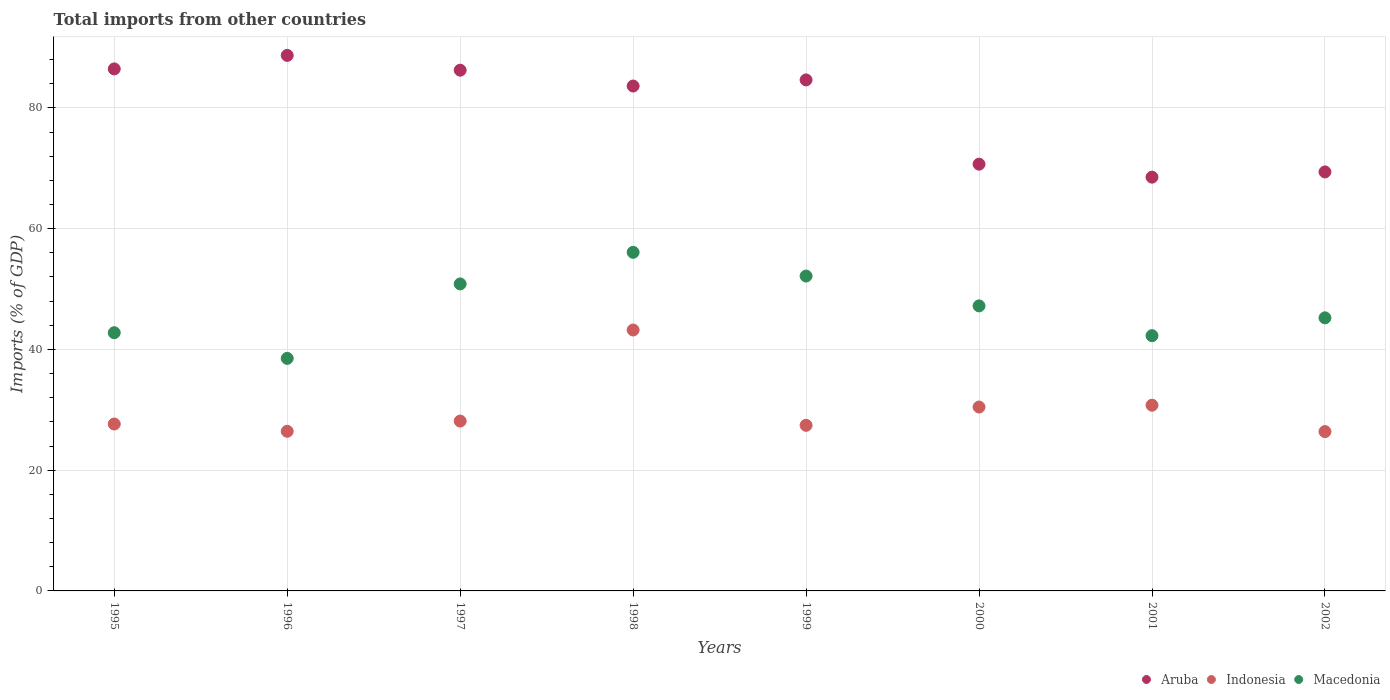How many different coloured dotlines are there?
Provide a succinct answer. 3. What is the total imports in Indonesia in 2000?
Offer a terse response. 30.46. Across all years, what is the maximum total imports in Aruba?
Provide a short and direct response. 88.7. Across all years, what is the minimum total imports in Indonesia?
Keep it short and to the point. 26.39. In which year was the total imports in Macedonia minimum?
Ensure brevity in your answer.  1996. What is the total total imports in Macedonia in the graph?
Ensure brevity in your answer.  375.1. What is the difference between the total imports in Aruba in 2001 and that in 2002?
Ensure brevity in your answer.  -0.87. What is the difference between the total imports in Macedonia in 1999 and the total imports in Aruba in 2001?
Keep it short and to the point. -16.38. What is the average total imports in Aruba per year?
Offer a very short reply. 79.79. In the year 1999, what is the difference between the total imports in Aruba and total imports in Macedonia?
Provide a short and direct response. 32.49. What is the ratio of the total imports in Aruba in 1995 to that in 1996?
Make the answer very short. 0.97. Is the total imports in Indonesia in 1998 less than that in 2002?
Make the answer very short. No. What is the difference between the highest and the second highest total imports in Aruba?
Your response must be concise. 2.24. What is the difference between the highest and the lowest total imports in Aruba?
Provide a short and direct response. 20.17. In how many years, is the total imports in Indonesia greater than the average total imports in Indonesia taken over all years?
Keep it short and to the point. 3. Does the total imports in Aruba monotonically increase over the years?
Give a very brief answer. No. Is the total imports in Indonesia strictly greater than the total imports in Macedonia over the years?
Offer a very short reply. No. Is the total imports in Indonesia strictly less than the total imports in Aruba over the years?
Keep it short and to the point. Yes. How many dotlines are there?
Give a very brief answer. 3. Does the graph contain any zero values?
Keep it short and to the point. No. Where does the legend appear in the graph?
Make the answer very short. Bottom right. How many legend labels are there?
Keep it short and to the point. 3. How are the legend labels stacked?
Your response must be concise. Horizontal. What is the title of the graph?
Keep it short and to the point. Total imports from other countries. Does "Latvia" appear as one of the legend labels in the graph?
Your answer should be very brief. No. What is the label or title of the Y-axis?
Offer a terse response. Imports (% of GDP). What is the Imports (% of GDP) of Aruba in 1995?
Provide a succinct answer. 86.46. What is the Imports (% of GDP) of Indonesia in 1995?
Your answer should be very brief. 27.65. What is the Imports (% of GDP) of Macedonia in 1995?
Provide a succinct answer. 42.77. What is the Imports (% of GDP) of Aruba in 1996?
Keep it short and to the point. 88.7. What is the Imports (% of GDP) of Indonesia in 1996?
Provide a succinct answer. 26.44. What is the Imports (% of GDP) of Macedonia in 1996?
Keep it short and to the point. 38.52. What is the Imports (% of GDP) of Aruba in 1997?
Provide a short and direct response. 86.25. What is the Imports (% of GDP) of Indonesia in 1997?
Make the answer very short. 28.13. What is the Imports (% of GDP) in Macedonia in 1997?
Offer a very short reply. 50.85. What is the Imports (% of GDP) in Aruba in 1998?
Ensure brevity in your answer.  83.63. What is the Imports (% of GDP) in Indonesia in 1998?
Your response must be concise. 43.22. What is the Imports (% of GDP) of Macedonia in 1998?
Provide a succinct answer. 56.09. What is the Imports (% of GDP) of Aruba in 1999?
Offer a terse response. 84.64. What is the Imports (% of GDP) in Indonesia in 1999?
Give a very brief answer. 27.43. What is the Imports (% of GDP) of Macedonia in 1999?
Offer a very short reply. 52.15. What is the Imports (% of GDP) of Aruba in 2000?
Provide a succinct answer. 70.69. What is the Imports (% of GDP) of Indonesia in 2000?
Your answer should be compact. 30.46. What is the Imports (% of GDP) of Macedonia in 2000?
Ensure brevity in your answer.  47.21. What is the Imports (% of GDP) of Aruba in 2001?
Your response must be concise. 68.53. What is the Imports (% of GDP) in Indonesia in 2001?
Offer a very short reply. 30.76. What is the Imports (% of GDP) of Macedonia in 2001?
Your answer should be very brief. 42.28. What is the Imports (% of GDP) of Aruba in 2002?
Provide a succinct answer. 69.4. What is the Imports (% of GDP) of Indonesia in 2002?
Offer a terse response. 26.39. What is the Imports (% of GDP) of Macedonia in 2002?
Your response must be concise. 45.23. Across all years, what is the maximum Imports (% of GDP) of Aruba?
Offer a terse response. 88.7. Across all years, what is the maximum Imports (% of GDP) in Indonesia?
Provide a short and direct response. 43.22. Across all years, what is the maximum Imports (% of GDP) in Macedonia?
Your response must be concise. 56.09. Across all years, what is the minimum Imports (% of GDP) of Aruba?
Your answer should be compact. 68.53. Across all years, what is the minimum Imports (% of GDP) in Indonesia?
Offer a very short reply. 26.39. Across all years, what is the minimum Imports (% of GDP) in Macedonia?
Your response must be concise. 38.52. What is the total Imports (% of GDP) in Aruba in the graph?
Offer a terse response. 638.31. What is the total Imports (% of GDP) in Indonesia in the graph?
Give a very brief answer. 240.48. What is the total Imports (% of GDP) in Macedonia in the graph?
Offer a terse response. 375.1. What is the difference between the Imports (% of GDP) in Aruba in 1995 and that in 1996?
Offer a terse response. -2.24. What is the difference between the Imports (% of GDP) of Indonesia in 1995 and that in 1996?
Give a very brief answer. 1.21. What is the difference between the Imports (% of GDP) of Macedonia in 1995 and that in 1996?
Provide a short and direct response. 4.25. What is the difference between the Imports (% of GDP) in Aruba in 1995 and that in 1997?
Give a very brief answer. 0.21. What is the difference between the Imports (% of GDP) in Indonesia in 1995 and that in 1997?
Your response must be concise. -0.49. What is the difference between the Imports (% of GDP) in Macedonia in 1995 and that in 1997?
Offer a very short reply. -8.08. What is the difference between the Imports (% of GDP) of Aruba in 1995 and that in 1998?
Offer a terse response. 2.83. What is the difference between the Imports (% of GDP) of Indonesia in 1995 and that in 1998?
Make the answer very short. -15.57. What is the difference between the Imports (% of GDP) of Macedonia in 1995 and that in 1998?
Make the answer very short. -13.32. What is the difference between the Imports (% of GDP) of Aruba in 1995 and that in 1999?
Keep it short and to the point. 1.82. What is the difference between the Imports (% of GDP) of Indonesia in 1995 and that in 1999?
Ensure brevity in your answer.  0.22. What is the difference between the Imports (% of GDP) in Macedonia in 1995 and that in 1999?
Keep it short and to the point. -9.39. What is the difference between the Imports (% of GDP) of Aruba in 1995 and that in 2000?
Ensure brevity in your answer.  15.78. What is the difference between the Imports (% of GDP) in Indonesia in 1995 and that in 2000?
Your answer should be compact. -2.81. What is the difference between the Imports (% of GDP) in Macedonia in 1995 and that in 2000?
Make the answer very short. -4.45. What is the difference between the Imports (% of GDP) in Aruba in 1995 and that in 2001?
Provide a short and direct response. 17.93. What is the difference between the Imports (% of GDP) of Indonesia in 1995 and that in 2001?
Give a very brief answer. -3.11. What is the difference between the Imports (% of GDP) in Macedonia in 1995 and that in 2001?
Give a very brief answer. 0.49. What is the difference between the Imports (% of GDP) of Aruba in 1995 and that in 2002?
Give a very brief answer. 17.06. What is the difference between the Imports (% of GDP) of Indonesia in 1995 and that in 2002?
Give a very brief answer. 1.25. What is the difference between the Imports (% of GDP) in Macedonia in 1995 and that in 2002?
Give a very brief answer. -2.46. What is the difference between the Imports (% of GDP) in Aruba in 1996 and that in 1997?
Make the answer very short. 2.45. What is the difference between the Imports (% of GDP) in Indonesia in 1996 and that in 1997?
Offer a very short reply. -1.69. What is the difference between the Imports (% of GDP) in Macedonia in 1996 and that in 1997?
Provide a short and direct response. -12.33. What is the difference between the Imports (% of GDP) in Aruba in 1996 and that in 1998?
Offer a very short reply. 5.07. What is the difference between the Imports (% of GDP) of Indonesia in 1996 and that in 1998?
Your answer should be very brief. -16.78. What is the difference between the Imports (% of GDP) of Macedonia in 1996 and that in 1998?
Offer a very short reply. -17.57. What is the difference between the Imports (% of GDP) in Aruba in 1996 and that in 1999?
Provide a short and direct response. 4.06. What is the difference between the Imports (% of GDP) of Indonesia in 1996 and that in 1999?
Your response must be concise. -0.99. What is the difference between the Imports (% of GDP) in Macedonia in 1996 and that in 1999?
Make the answer very short. -13.64. What is the difference between the Imports (% of GDP) of Aruba in 1996 and that in 2000?
Make the answer very short. 18.02. What is the difference between the Imports (% of GDP) in Indonesia in 1996 and that in 2000?
Provide a succinct answer. -4.02. What is the difference between the Imports (% of GDP) in Macedonia in 1996 and that in 2000?
Your answer should be compact. -8.7. What is the difference between the Imports (% of GDP) of Aruba in 1996 and that in 2001?
Your answer should be compact. 20.17. What is the difference between the Imports (% of GDP) in Indonesia in 1996 and that in 2001?
Offer a very short reply. -4.32. What is the difference between the Imports (% of GDP) of Macedonia in 1996 and that in 2001?
Your response must be concise. -3.76. What is the difference between the Imports (% of GDP) of Aruba in 1996 and that in 2002?
Provide a succinct answer. 19.3. What is the difference between the Imports (% of GDP) of Indonesia in 1996 and that in 2002?
Provide a short and direct response. 0.05. What is the difference between the Imports (% of GDP) in Macedonia in 1996 and that in 2002?
Your answer should be very brief. -6.72. What is the difference between the Imports (% of GDP) of Aruba in 1997 and that in 1998?
Offer a very short reply. 2.62. What is the difference between the Imports (% of GDP) in Indonesia in 1997 and that in 1998?
Provide a short and direct response. -15.08. What is the difference between the Imports (% of GDP) in Macedonia in 1997 and that in 1998?
Provide a succinct answer. -5.24. What is the difference between the Imports (% of GDP) of Aruba in 1997 and that in 1999?
Your response must be concise. 1.61. What is the difference between the Imports (% of GDP) in Indonesia in 1997 and that in 1999?
Provide a succinct answer. 0.7. What is the difference between the Imports (% of GDP) of Macedonia in 1997 and that in 1999?
Make the answer very short. -1.3. What is the difference between the Imports (% of GDP) in Aruba in 1997 and that in 2000?
Give a very brief answer. 15.56. What is the difference between the Imports (% of GDP) in Indonesia in 1997 and that in 2000?
Provide a short and direct response. -2.32. What is the difference between the Imports (% of GDP) of Macedonia in 1997 and that in 2000?
Your response must be concise. 3.64. What is the difference between the Imports (% of GDP) in Aruba in 1997 and that in 2001?
Offer a very short reply. 17.72. What is the difference between the Imports (% of GDP) of Indonesia in 1997 and that in 2001?
Your answer should be very brief. -2.63. What is the difference between the Imports (% of GDP) in Macedonia in 1997 and that in 2001?
Make the answer very short. 8.57. What is the difference between the Imports (% of GDP) of Aruba in 1997 and that in 2002?
Your answer should be compact. 16.85. What is the difference between the Imports (% of GDP) in Indonesia in 1997 and that in 2002?
Your response must be concise. 1.74. What is the difference between the Imports (% of GDP) of Macedonia in 1997 and that in 2002?
Ensure brevity in your answer.  5.62. What is the difference between the Imports (% of GDP) of Aruba in 1998 and that in 1999?
Make the answer very short. -1.01. What is the difference between the Imports (% of GDP) of Indonesia in 1998 and that in 1999?
Ensure brevity in your answer.  15.79. What is the difference between the Imports (% of GDP) of Macedonia in 1998 and that in 1999?
Offer a terse response. 3.93. What is the difference between the Imports (% of GDP) in Aruba in 1998 and that in 2000?
Your response must be concise. 12.94. What is the difference between the Imports (% of GDP) in Indonesia in 1998 and that in 2000?
Ensure brevity in your answer.  12.76. What is the difference between the Imports (% of GDP) of Macedonia in 1998 and that in 2000?
Ensure brevity in your answer.  8.87. What is the difference between the Imports (% of GDP) in Aruba in 1998 and that in 2001?
Provide a short and direct response. 15.1. What is the difference between the Imports (% of GDP) of Indonesia in 1998 and that in 2001?
Ensure brevity in your answer.  12.46. What is the difference between the Imports (% of GDP) in Macedonia in 1998 and that in 2001?
Provide a succinct answer. 13.81. What is the difference between the Imports (% of GDP) of Aruba in 1998 and that in 2002?
Provide a succinct answer. 14.23. What is the difference between the Imports (% of GDP) in Indonesia in 1998 and that in 2002?
Your answer should be very brief. 16.83. What is the difference between the Imports (% of GDP) in Macedonia in 1998 and that in 2002?
Give a very brief answer. 10.85. What is the difference between the Imports (% of GDP) of Aruba in 1999 and that in 2000?
Your answer should be very brief. 13.96. What is the difference between the Imports (% of GDP) in Indonesia in 1999 and that in 2000?
Your answer should be very brief. -3.03. What is the difference between the Imports (% of GDP) of Macedonia in 1999 and that in 2000?
Keep it short and to the point. 4.94. What is the difference between the Imports (% of GDP) of Aruba in 1999 and that in 2001?
Ensure brevity in your answer.  16.11. What is the difference between the Imports (% of GDP) in Indonesia in 1999 and that in 2001?
Provide a short and direct response. -3.33. What is the difference between the Imports (% of GDP) of Macedonia in 1999 and that in 2001?
Make the answer very short. 9.87. What is the difference between the Imports (% of GDP) in Aruba in 1999 and that in 2002?
Make the answer very short. 15.24. What is the difference between the Imports (% of GDP) in Indonesia in 1999 and that in 2002?
Give a very brief answer. 1.04. What is the difference between the Imports (% of GDP) of Macedonia in 1999 and that in 2002?
Provide a succinct answer. 6.92. What is the difference between the Imports (% of GDP) of Aruba in 2000 and that in 2001?
Offer a terse response. 2.15. What is the difference between the Imports (% of GDP) in Indonesia in 2000 and that in 2001?
Provide a short and direct response. -0.3. What is the difference between the Imports (% of GDP) of Macedonia in 2000 and that in 2001?
Your answer should be very brief. 4.93. What is the difference between the Imports (% of GDP) of Aruba in 2000 and that in 2002?
Ensure brevity in your answer.  1.29. What is the difference between the Imports (% of GDP) of Indonesia in 2000 and that in 2002?
Offer a very short reply. 4.07. What is the difference between the Imports (% of GDP) of Macedonia in 2000 and that in 2002?
Your answer should be compact. 1.98. What is the difference between the Imports (% of GDP) of Aruba in 2001 and that in 2002?
Your answer should be compact. -0.87. What is the difference between the Imports (% of GDP) in Indonesia in 2001 and that in 2002?
Your answer should be compact. 4.37. What is the difference between the Imports (% of GDP) in Macedonia in 2001 and that in 2002?
Ensure brevity in your answer.  -2.95. What is the difference between the Imports (% of GDP) of Aruba in 1995 and the Imports (% of GDP) of Indonesia in 1996?
Your response must be concise. 60.02. What is the difference between the Imports (% of GDP) of Aruba in 1995 and the Imports (% of GDP) of Macedonia in 1996?
Give a very brief answer. 47.95. What is the difference between the Imports (% of GDP) of Indonesia in 1995 and the Imports (% of GDP) of Macedonia in 1996?
Keep it short and to the point. -10.87. What is the difference between the Imports (% of GDP) in Aruba in 1995 and the Imports (% of GDP) in Indonesia in 1997?
Offer a very short reply. 58.33. What is the difference between the Imports (% of GDP) of Aruba in 1995 and the Imports (% of GDP) of Macedonia in 1997?
Provide a short and direct response. 35.61. What is the difference between the Imports (% of GDP) of Indonesia in 1995 and the Imports (% of GDP) of Macedonia in 1997?
Your response must be concise. -23.2. What is the difference between the Imports (% of GDP) in Aruba in 1995 and the Imports (% of GDP) in Indonesia in 1998?
Keep it short and to the point. 43.25. What is the difference between the Imports (% of GDP) in Aruba in 1995 and the Imports (% of GDP) in Macedonia in 1998?
Your response must be concise. 30.38. What is the difference between the Imports (% of GDP) in Indonesia in 1995 and the Imports (% of GDP) in Macedonia in 1998?
Offer a very short reply. -28.44. What is the difference between the Imports (% of GDP) of Aruba in 1995 and the Imports (% of GDP) of Indonesia in 1999?
Ensure brevity in your answer.  59.03. What is the difference between the Imports (% of GDP) of Aruba in 1995 and the Imports (% of GDP) of Macedonia in 1999?
Give a very brief answer. 34.31. What is the difference between the Imports (% of GDP) of Indonesia in 1995 and the Imports (% of GDP) of Macedonia in 1999?
Make the answer very short. -24.51. What is the difference between the Imports (% of GDP) in Aruba in 1995 and the Imports (% of GDP) in Indonesia in 2000?
Offer a terse response. 56. What is the difference between the Imports (% of GDP) of Aruba in 1995 and the Imports (% of GDP) of Macedonia in 2000?
Make the answer very short. 39.25. What is the difference between the Imports (% of GDP) in Indonesia in 1995 and the Imports (% of GDP) in Macedonia in 2000?
Your answer should be very brief. -19.57. What is the difference between the Imports (% of GDP) in Aruba in 1995 and the Imports (% of GDP) in Indonesia in 2001?
Offer a very short reply. 55.7. What is the difference between the Imports (% of GDP) in Aruba in 1995 and the Imports (% of GDP) in Macedonia in 2001?
Provide a succinct answer. 44.18. What is the difference between the Imports (% of GDP) of Indonesia in 1995 and the Imports (% of GDP) of Macedonia in 2001?
Your answer should be compact. -14.63. What is the difference between the Imports (% of GDP) in Aruba in 1995 and the Imports (% of GDP) in Indonesia in 2002?
Provide a succinct answer. 60.07. What is the difference between the Imports (% of GDP) of Aruba in 1995 and the Imports (% of GDP) of Macedonia in 2002?
Keep it short and to the point. 41.23. What is the difference between the Imports (% of GDP) of Indonesia in 1995 and the Imports (% of GDP) of Macedonia in 2002?
Provide a short and direct response. -17.59. What is the difference between the Imports (% of GDP) of Aruba in 1996 and the Imports (% of GDP) of Indonesia in 1997?
Provide a short and direct response. 60.57. What is the difference between the Imports (% of GDP) of Aruba in 1996 and the Imports (% of GDP) of Macedonia in 1997?
Provide a succinct answer. 37.85. What is the difference between the Imports (% of GDP) in Indonesia in 1996 and the Imports (% of GDP) in Macedonia in 1997?
Keep it short and to the point. -24.41. What is the difference between the Imports (% of GDP) of Aruba in 1996 and the Imports (% of GDP) of Indonesia in 1998?
Your response must be concise. 45.49. What is the difference between the Imports (% of GDP) of Aruba in 1996 and the Imports (% of GDP) of Macedonia in 1998?
Ensure brevity in your answer.  32.62. What is the difference between the Imports (% of GDP) in Indonesia in 1996 and the Imports (% of GDP) in Macedonia in 1998?
Provide a short and direct response. -29.65. What is the difference between the Imports (% of GDP) in Aruba in 1996 and the Imports (% of GDP) in Indonesia in 1999?
Offer a terse response. 61.27. What is the difference between the Imports (% of GDP) of Aruba in 1996 and the Imports (% of GDP) of Macedonia in 1999?
Your answer should be compact. 36.55. What is the difference between the Imports (% of GDP) of Indonesia in 1996 and the Imports (% of GDP) of Macedonia in 1999?
Offer a very short reply. -25.71. What is the difference between the Imports (% of GDP) in Aruba in 1996 and the Imports (% of GDP) in Indonesia in 2000?
Your answer should be very brief. 58.24. What is the difference between the Imports (% of GDP) of Aruba in 1996 and the Imports (% of GDP) of Macedonia in 2000?
Offer a terse response. 41.49. What is the difference between the Imports (% of GDP) of Indonesia in 1996 and the Imports (% of GDP) of Macedonia in 2000?
Provide a short and direct response. -20.77. What is the difference between the Imports (% of GDP) in Aruba in 1996 and the Imports (% of GDP) in Indonesia in 2001?
Your answer should be very brief. 57.94. What is the difference between the Imports (% of GDP) of Aruba in 1996 and the Imports (% of GDP) of Macedonia in 2001?
Give a very brief answer. 46.43. What is the difference between the Imports (% of GDP) in Indonesia in 1996 and the Imports (% of GDP) in Macedonia in 2001?
Offer a very short reply. -15.84. What is the difference between the Imports (% of GDP) of Aruba in 1996 and the Imports (% of GDP) of Indonesia in 2002?
Your answer should be compact. 62.31. What is the difference between the Imports (% of GDP) in Aruba in 1996 and the Imports (% of GDP) in Macedonia in 2002?
Your answer should be compact. 43.47. What is the difference between the Imports (% of GDP) of Indonesia in 1996 and the Imports (% of GDP) of Macedonia in 2002?
Your answer should be compact. -18.79. What is the difference between the Imports (% of GDP) of Aruba in 1997 and the Imports (% of GDP) of Indonesia in 1998?
Your answer should be compact. 43.03. What is the difference between the Imports (% of GDP) of Aruba in 1997 and the Imports (% of GDP) of Macedonia in 1998?
Keep it short and to the point. 30.17. What is the difference between the Imports (% of GDP) in Indonesia in 1997 and the Imports (% of GDP) in Macedonia in 1998?
Provide a succinct answer. -27.95. What is the difference between the Imports (% of GDP) in Aruba in 1997 and the Imports (% of GDP) in Indonesia in 1999?
Ensure brevity in your answer.  58.82. What is the difference between the Imports (% of GDP) of Aruba in 1997 and the Imports (% of GDP) of Macedonia in 1999?
Provide a short and direct response. 34.1. What is the difference between the Imports (% of GDP) of Indonesia in 1997 and the Imports (% of GDP) of Macedonia in 1999?
Your answer should be very brief. -24.02. What is the difference between the Imports (% of GDP) of Aruba in 1997 and the Imports (% of GDP) of Indonesia in 2000?
Ensure brevity in your answer.  55.79. What is the difference between the Imports (% of GDP) of Aruba in 1997 and the Imports (% of GDP) of Macedonia in 2000?
Give a very brief answer. 39.04. What is the difference between the Imports (% of GDP) of Indonesia in 1997 and the Imports (% of GDP) of Macedonia in 2000?
Offer a very short reply. -19.08. What is the difference between the Imports (% of GDP) in Aruba in 1997 and the Imports (% of GDP) in Indonesia in 2001?
Make the answer very short. 55.49. What is the difference between the Imports (% of GDP) of Aruba in 1997 and the Imports (% of GDP) of Macedonia in 2001?
Offer a very short reply. 43.97. What is the difference between the Imports (% of GDP) in Indonesia in 1997 and the Imports (% of GDP) in Macedonia in 2001?
Offer a very short reply. -14.14. What is the difference between the Imports (% of GDP) in Aruba in 1997 and the Imports (% of GDP) in Indonesia in 2002?
Ensure brevity in your answer.  59.86. What is the difference between the Imports (% of GDP) of Aruba in 1997 and the Imports (% of GDP) of Macedonia in 2002?
Your answer should be very brief. 41.02. What is the difference between the Imports (% of GDP) in Indonesia in 1997 and the Imports (% of GDP) in Macedonia in 2002?
Provide a succinct answer. -17.1. What is the difference between the Imports (% of GDP) of Aruba in 1998 and the Imports (% of GDP) of Indonesia in 1999?
Make the answer very short. 56.2. What is the difference between the Imports (% of GDP) in Aruba in 1998 and the Imports (% of GDP) in Macedonia in 1999?
Give a very brief answer. 31.48. What is the difference between the Imports (% of GDP) in Indonesia in 1998 and the Imports (% of GDP) in Macedonia in 1999?
Your answer should be compact. -8.94. What is the difference between the Imports (% of GDP) in Aruba in 1998 and the Imports (% of GDP) in Indonesia in 2000?
Ensure brevity in your answer.  53.17. What is the difference between the Imports (% of GDP) in Aruba in 1998 and the Imports (% of GDP) in Macedonia in 2000?
Provide a succinct answer. 36.42. What is the difference between the Imports (% of GDP) of Indonesia in 1998 and the Imports (% of GDP) of Macedonia in 2000?
Offer a terse response. -4. What is the difference between the Imports (% of GDP) of Aruba in 1998 and the Imports (% of GDP) of Indonesia in 2001?
Your response must be concise. 52.87. What is the difference between the Imports (% of GDP) in Aruba in 1998 and the Imports (% of GDP) in Macedonia in 2001?
Provide a succinct answer. 41.35. What is the difference between the Imports (% of GDP) in Indonesia in 1998 and the Imports (% of GDP) in Macedonia in 2001?
Your answer should be very brief. 0.94. What is the difference between the Imports (% of GDP) in Aruba in 1998 and the Imports (% of GDP) in Indonesia in 2002?
Your response must be concise. 57.24. What is the difference between the Imports (% of GDP) of Aruba in 1998 and the Imports (% of GDP) of Macedonia in 2002?
Offer a very short reply. 38.4. What is the difference between the Imports (% of GDP) of Indonesia in 1998 and the Imports (% of GDP) of Macedonia in 2002?
Give a very brief answer. -2.01. What is the difference between the Imports (% of GDP) of Aruba in 1999 and the Imports (% of GDP) of Indonesia in 2000?
Keep it short and to the point. 54.18. What is the difference between the Imports (% of GDP) of Aruba in 1999 and the Imports (% of GDP) of Macedonia in 2000?
Give a very brief answer. 37.43. What is the difference between the Imports (% of GDP) in Indonesia in 1999 and the Imports (% of GDP) in Macedonia in 2000?
Ensure brevity in your answer.  -19.78. What is the difference between the Imports (% of GDP) in Aruba in 1999 and the Imports (% of GDP) in Indonesia in 2001?
Ensure brevity in your answer.  53.88. What is the difference between the Imports (% of GDP) of Aruba in 1999 and the Imports (% of GDP) of Macedonia in 2001?
Your answer should be very brief. 42.36. What is the difference between the Imports (% of GDP) in Indonesia in 1999 and the Imports (% of GDP) in Macedonia in 2001?
Make the answer very short. -14.85. What is the difference between the Imports (% of GDP) of Aruba in 1999 and the Imports (% of GDP) of Indonesia in 2002?
Keep it short and to the point. 58.25. What is the difference between the Imports (% of GDP) in Aruba in 1999 and the Imports (% of GDP) in Macedonia in 2002?
Your response must be concise. 39.41. What is the difference between the Imports (% of GDP) of Indonesia in 1999 and the Imports (% of GDP) of Macedonia in 2002?
Offer a terse response. -17.8. What is the difference between the Imports (% of GDP) of Aruba in 2000 and the Imports (% of GDP) of Indonesia in 2001?
Your answer should be compact. 39.93. What is the difference between the Imports (% of GDP) in Aruba in 2000 and the Imports (% of GDP) in Macedonia in 2001?
Your response must be concise. 28.41. What is the difference between the Imports (% of GDP) in Indonesia in 2000 and the Imports (% of GDP) in Macedonia in 2001?
Your answer should be very brief. -11.82. What is the difference between the Imports (% of GDP) in Aruba in 2000 and the Imports (% of GDP) in Indonesia in 2002?
Offer a very short reply. 44.3. What is the difference between the Imports (% of GDP) of Aruba in 2000 and the Imports (% of GDP) of Macedonia in 2002?
Give a very brief answer. 25.45. What is the difference between the Imports (% of GDP) of Indonesia in 2000 and the Imports (% of GDP) of Macedonia in 2002?
Make the answer very short. -14.77. What is the difference between the Imports (% of GDP) of Aruba in 2001 and the Imports (% of GDP) of Indonesia in 2002?
Provide a short and direct response. 42.14. What is the difference between the Imports (% of GDP) of Aruba in 2001 and the Imports (% of GDP) of Macedonia in 2002?
Offer a very short reply. 23.3. What is the difference between the Imports (% of GDP) of Indonesia in 2001 and the Imports (% of GDP) of Macedonia in 2002?
Your answer should be compact. -14.47. What is the average Imports (% of GDP) in Aruba per year?
Provide a succinct answer. 79.79. What is the average Imports (% of GDP) in Indonesia per year?
Offer a very short reply. 30.06. What is the average Imports (% of GDP) in Macedonia per year?
Ensure brevity in your answer.  46.89. In the year 1995, what is the difference between the Imports (% of GDP) in Aruba and Imports (% of GDP) in Indonesia?
Make the answer very short. 58.82. In the year 1995, what is the difference between the Imports (% of GDP) in Aruba and Imports (% of GDP) in Macedonia?
Give a very brief answer. 43.7. In the year 1995, what is the difference between the Imports (% of GDP) in Indonesia and Imports (% of GDP) in Macedonia?
Keep it short and to the point. -15.12. In the year 1996, what is the difference between the Imports (% of GDP) of Aruba and Imports (% of GDP) of Indonesia?
Provide a short and direct response. 62.26. In the year 1996, what is the difference between the Imports (% of GDP) in Aruba and Imports (% of GDP) in Macedonia?
Give a very brief answer. 50.19. In the year 1996, what is the difference between the Imports (% of GDP) in Indonesia and Imports (% of GDP) in Macedonia?
Make the answer very short. -12.08. In the year 1997, what is the difference between the Imports (% of GDP) of Aruba and Imports (% of GDP) of Indonesia?
Offer a terse response. 58.12. In the year 1997, what is the difference between the Imports (% of GDP) of Aruba and Imports (% of GDP) of Macedonia?
Keep it short and to the point. 35.4. In the year 1997, what is the difference between the Imports (% of GDP) in Indonesia and Imports (% of GDP) in Macedonia?
Make the answer very short. -22.72. In the year 1998, what is the difference between the Imports (% of GDP) of Aruba and Imports (% of GDP) of Indonesia?
Give a very brief answer. 40.41. In the year 1998, what is the difference between the Imports (% of GDP) of Aruba and Imports (% of GDP) of Macedonia?
Offer a very short reply. 27.54. In the year 1998, what is the difference between the Imports (% of GDP) of Indonesia and Imports (% of GDP) of Macedonia?
Give a very brief answer. -12.87. In the year 1999, what is the difference between the Imports (% of GDP) in Aruba and Imports (% of GDP) in Indonesia?
Make the answer very short. 57.21. In the year 1999, what is the difference between the Imports (% of GDP) in Aruba and Imports (% of GDP) in Macedonia?
Offer a terse response. 32.49. In the year 1999, what is the difference between the Imports (% of GDP) of Indonesia and Imports (% of GDP) of Macedonia?
Offer a terse response. -24.72. In the year 2000, what is the difference between the Imports (% of GDP) of Aruba and Imports (% of GDP) of Indonesia?
Provide a succinct answer. 40.23. In the year 2000, what is the difference between the Imports (% of GDP) of Aruba and Imports (% of GDP) of Macedonia?
Ensure brevity in your answer.  23.47. In the year 2000, what is the difference between the Imports (% of GDP) in Indonesia and Imports (% of GDP) in Macedonia?
Ensure brevity in your answer.  -16.75. In the year 2001, what is the difference between the Imports (% of GDP) in Aruba and Imports (% of GDP) in Indonesia?
Give a very brief answer. 37.77. In the year 2001, what is the difference between the Imports (% of GDP) in Aruba and Imports (% of GDP) in Macedonia?
Keep it short and to the point. 26.25. In the year 2001, what is the difference between the Imports (% of GDP) of Indonesia and Imports (% of GDP) of Macedonia?
Your answer should be compact. -11.52. In the year 2002, what is the difference between the Imports (% of GDP) in Aruba and Imports (% of GDP) in Indonesia?
Ensure brevity in your answer.  43.01. In the year 2002, what is the difference between the Imports (% of GDP) of Aruba and Imports (% of GDP) of Macedonia?
Offer a very short reply. 24.17. In the year 2002, what is the difference between the Imports (% of GDP) of Indonesia and Imports (% of GDP) of Macedonia?
Provide a short and direct response. -18.84. What is the ratio of the Imports (% of GDP) of Aruba in 1995 to that in 1996?
Provide a short and direct response. 0.97. What is the ratio of the Imports (% of GDP) in Indonesia in 1995 to that in 1996?
Offer a terse response. 1.05. What is the ratio of the Imports (% of GDP) of Macedonia in 1995 to that in 1996?
Offer a terse response. 1.11. What is the ratio of the Imports (% of GDP) of Indonesia in 1995 to that in 1997?
Offer a terse response. 0.98. What is the ratio of the Imports (% of GDP) of Macedonia in 1995 to that in 1997?
Provide a short and direct response. 0.84. What is the ratio of the Imports (% of GDP) in Aruba in 1995 to that in 1998?
Your response must be concise. 1.03. What is the ratio of the Imports (% of GDP) of Indonesia in 1995 to that in 1998?
Keep it short and to the point. 0.64. What is the ratio of the Imports (% of GDP) of Macedonia in 1995 to that in 1998?
Ensure brevity in your answer.  0.76. What is the ratio of the Imports (% of GDP) of Aruba in 1995 to that in 1999?
Your answer should be very brief. 1.02. What is the ratio of the Imports (% of GDP) of Indonesia in 1995 to that in 1999?
Provide a succinct answer. 1.01. What is the ratio of the Imports (% of GDP) of Macedonia in 1995 to that in 1999?
Make the answer very short. 0.82. What is the ratio of the Imports (% of GDP) in Aruba in 1995 to that in 2000?
Provide a short and direct response. 1.22. What is the ratio of the Imports (% of GDP) in Indonesia in 1995 to that in 2000?
Make the answer very short. 0.91. What is the ratio of the Imports (% of GDP) of Macedonia in 1995 to that in 2000?
Your answer should be very brief. 0.91. What is the ratio of the Imports (% of GDP) in Aruba in 1995 to that in 2001?
Keep it short and to the point. 1.26. What is the ratio of the Imports (% of GDP) of Indonesia in 1995 to that in 2001?
Ensure brevity in your answer.  0.9. What is the ratio of the Imports (% of GDP) of Macedonia in 1995 to that in 2001?
Your answer should be very brief. 1.01. What is the ratio of the Imports (% of GDP) of Aruba in 1995 to that in 2002?
Keep it short and to the point. 1.25. What is the ratio of the Imports (% of GDP) of Indonesia in 1995 to that in 2002?
Provide a short and direct response. 1.05. What is the ratio of the Imports (% of GDP) in Macedonia in 1995 to that in 2002?
Your answer should be compact. 0.95. What is the ratio of the Imports (% of GDP) of Aruba in 1996 to that in 1997?
Offer a very short reply. 1.03. What is the ratio of the Imports (% of GDP) in Indonesia in 1996 to that in 1997?
Your response must be concise. 0.94. What is the ratio of the Imports (% of GDP) of Macedonia in 1996 to that in 1997?
Give a very brief answer. 0.76. What is the ratio of the Imports (% of GDP) in Aruba in 1996 to that in 1998?
Your response must be concise. 1.06. What is the ratio of the Imports (% of GDP) of Indonesia in 1996 to that in 1998?
Your answer should be very brief. 0.61. What is the ratio of the Imports (% of GDP) of Macedonia in 1996 to that in 1998?
Your answer should be compact. 0.69. What is the ratio of the Imports (% of GDP) of Aruba in 1996 to that in 1999?
Your answer should be very brief. 1.05. What is the ratio of the Imports (% of GDP) of Indonesia in 1996 to that in 1999?
Keep it short and to the point. 0.96. What is the ratio of the Imports (% of GDP) in Macedonia in 1996 to that in 1999?
Ensure brevity in your answer.  0.74. What is the ratio of the Imports (% of GDP) in Aruba in 1996 to that in 2000?
Give a very brief answer. 1.25. What is the ratio of the Imports (% of GDP) in Indonesia in 1996 to that in 2000?
Provide a succinct answer. 0.87. What is the ratio of the Imports (% of GDP) in Macedonia in 1996 to that in 2000?
Your answer should be very brief. 0.82. What is the ratio of the Imports (% of GDP) in Aruba in 1996 to that in 2001?
Make the answer very short. 1.29. What is the ratio of the Imports (% of GDP) of Indonesia in 1996 to that in 2001?
Offer a very short reply. 0.86. What is the ratio of the Imports (% of GDP) of Macedonia in 1996 to that in 2001?
Offer a very short reply. 0.91. What is the ratio of the Imports (% of GDP) in Aruba in 1996 to that in 2002?
Keep it short and to the point. 1.28. What is the ratio of the Imports (% of GDP) in Macedonia in 1996 to that in 2002?
Ensure brevity in your answer.  0.85. What is the ratio of the Imports (% of GDP) of Aruba in 1997 to that in 1998?
Make the answer very short. 1.03. What is the ratio of the Imports (% of GDP) in Indonesia in 1997 to that in 1998?
Provide a short and direct response. 0.65. What is the ratio of the Imports (% of GDP) in Macedonia in 1997 to that in 1998?
Ensure brevity in your answer.  0.91. What is the ratio of the Imports (% of GDP) in Indonesia in 1997 to that in 1999?
Offer a very short reply. 1.03. What is the ratio of the Imports (% of GDP) of Macedonia in 1997 to that in 1999?
Your response must be concise. 0.97. What is the ratio of the Imports (% of GDP) in Aruba in 1997 to that in 2000?
Make the answer very short. 1.22. What is the ratio of the Imports (% of GDP) in Indonesia in 1997 to that in 2000?
Offer a very short reply. 0.92. What is the ratio of the Imports (% of GDP) of Macedonia in 1997 to that in 2000?
Offer a terse response. 1.08. What is the ratio of the Imports (% of GDP) in Aruba in 1997 to that in 2001?
Your response must be concise. 1.26. What is the ratio of the Imports (% of GDP) of Indonesia in 1997 to that in 2001?
Provide a succinct answer. 0.91. What is the ratio of the Imports (% of GDP) of Macedonia in 1997 to that in 2001?
Give a very brief answer. 1.2. What is the ratio of the Imports (% of GDP) in Aruba in 1997 to that in 2002?
Offer a very short reply. 1.24. What is the ratio of the Imports (% of GDP) in Indonesia in 1997 to that in 2002?
Give a very brief answer. 1.07. What is the ratio of the Imports (% of GDP) in Macedonia in 1997 to that in 2002?
Your answer should be compact. 1.12. What is the ratio of the Imports (% of GDP) in Aruba in 1998 to that in 1999?
Provide a short and direct response. 0.99. What is the ratio of the Imports (% of GDP) of Indonesia in 1998 to that in 1999?
Give a very brief answer. 1.58. What is the ratio of the Imports (% of GDP) in Macedonia in 1998 to that in 1999?
Ensure brevity in your answer.  1.08. What is the ratio of the Imports (% of GDP) in Aruba in 1998 to that in 2000?
Ensure brevity in your answer.  1.18. What is the ratio of the Imports (% of GDP) in Indonesia in 1998 to that in 2000?
Your response must be concise. 1.42. What is the ratio of the Imports (% of GDP) in Macedonia in 1998 to that in 2000?
Your response must be concise. 1.19. What is the ratio of the Imports (% of GDP) of Aruba in 1998 to that in 2001?
Ensure brevity in your answer.  1.22. What is the ratio of the Imports (% of GDP) in Indonesia in 1998 to that in 2001?
Offer a terse response. 1.41. What is the ratio of the Imports (% of GDP) in Macedonia in 1998 to that in 2001?
Your answer should be compact. 1.33. What is the ratio of the Imports (% of GDP) of Aruba in 1998 to that in 2002?
Offer a terse response. 1.21. What is the ratio of the Imports (% of GDP) in Indonesia in 1998 to that in 2002?
Give a very brief answer. 1.64. What is the ratio of the Imports (% of GDP) in Macedonia in 1998 to that in 2002?
Your answer should be very brief. 1.24. What is the ratio of the Imports (% of GDP) of Aruba in 1999 to that in 2000?
Offer a very short reply. 1.2. What is the ratio of the Imports (% of GDP) of Indonesia in 1999 to that in 2000?
Give a very brief answer. 0.9. What is the ratio of the Imports (% of GDP) of Macedonia in 1999 to that in 2000?
Give a very brief answer. 1.1. What is the ratio of the Imports (% of GDP) of Aruba in 1999 to that in 2001?
Provide a short and direct response. 1.24. What is the ratio of the Imports (% of GDP) in Indonesia in 1999 to that in 2001?
Provide a short and direct response. 0.89. What is the ratio of the Imports (% of GDP) of Macedonia in 1999 to that in 2001?
Offer a very short reply. 1.23. What is the ratio of the Imports (% of GDP) of Aruba in 1999 to that in 2002?
Give a very brief answer. 1.22. What is the ratio of the Imports (% of GDP) of Indonesia in 1999 to that in 2002?
Your answer should be compact. 1.04. What is the ratio of the Imports (% of GDP) of Macedonia in 1999 to that in 2002?
Offer a very short reply. 1.15. What is the ratio of the Imports (% of GDP) in Aruba in 2000 to that in 2001?
Keep it short and to the point. 1.03. What is the ratio of the Imports (% of GDP) in Indonesia in 2000 to that in 2001?
Make the answer very short. 0.99. What is the ratio of the Imports (% of GDP) of Macedonia in 2000 to that in 2001?
Give a very brief answer. 1.12. What is the ratio of the Imports (% of GDP) in Aruba in 2000 to that in 2002?
Keep it short and to the point. 1.02. What is the ratio of the Imports (% of GDP) in Indonesia in 2000 to that in 2002?
Keep it short and to the point. 1.15. What is the ratio of the Imports (% of GDP) in Macedonia in 2000 to that in 2002?
Your answer should be compact. 1.04. What is the ratio of the Imports (% of GDP) of Aruba in 2001 to that in 2002?
Your answer should be very brief. 0.99. What is the ratio of the Imports (% of GDP) of Indonesia in 2001 to that in 2002?
Offer a very short reply. 1.17. What is the ratio of the Imports (% of GDP) of Macedonia in 2001 to that in 2002?
Keep it short and to the point. 0.93. What is the difference between the highest and the second highest Imports (% of GDP) of Aruba?
Offer a terse response. 2.24. What is the difference between the highest and the second highest Imports (% of GDP) of Indonesia?
Your answer should be compact. 12.46. What is the difference between the highest and the second highest Imports (% of GDP) of Macedonia?
Keep it short and to the point. 3.93. What is the difference between the highest and the lowest Imports (% of GDP) in Aruba?
Keep it short and to the point. 20.17. What is the difference between the highest and the lowest Imports (% of GDP) of Indonesia?
Ensure brevity in your answer.  16.83. What is the difference between the highest and the lowest Imports (% of GDP) in Macedonia?
Keep it short and to the point. 17.57. 